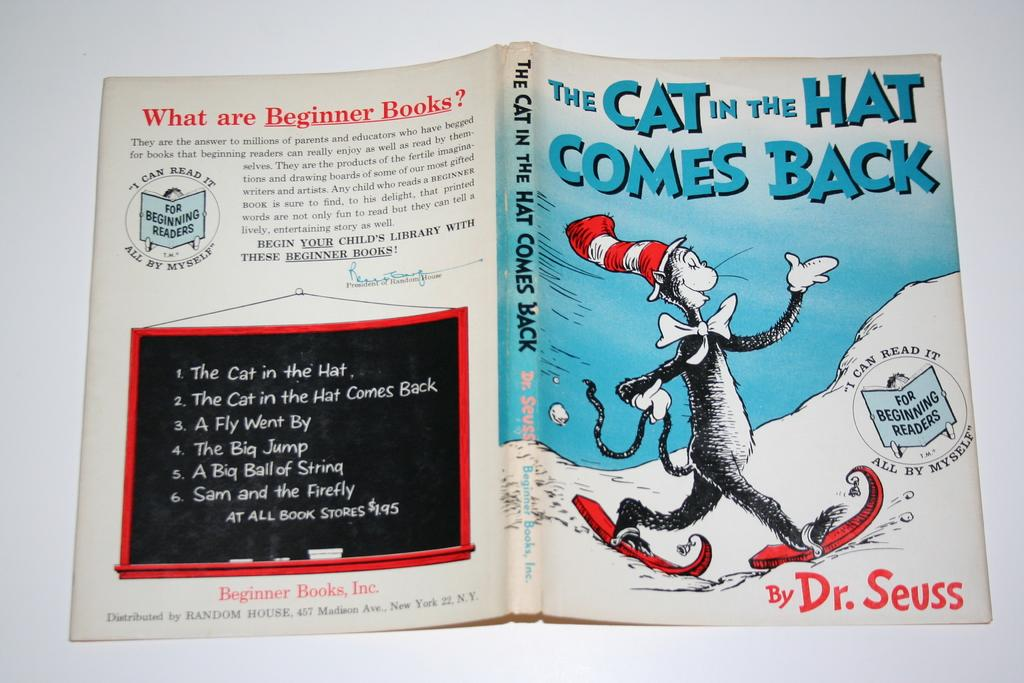<image>
Provide a brief description of the given image. The Cat in the Hat Comes Back was written by Dr. Seuss. 